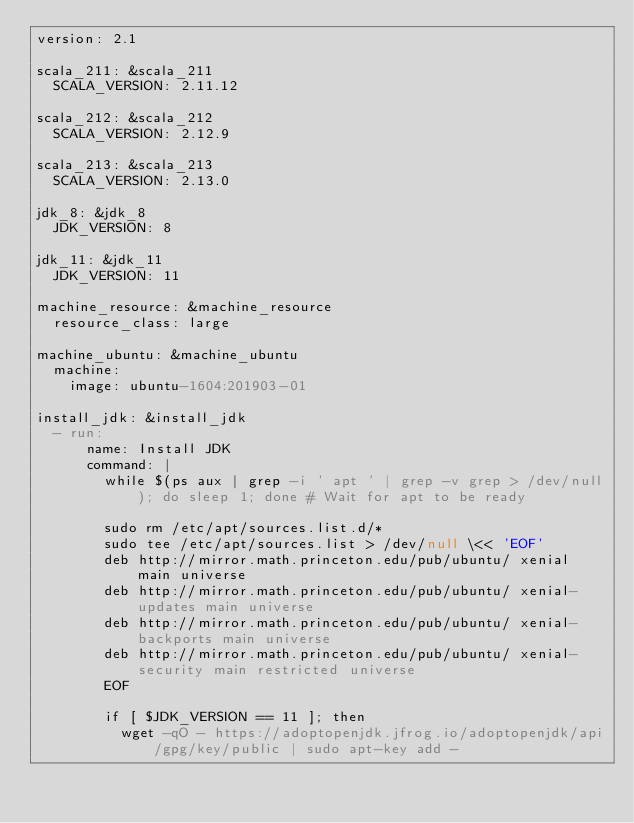Convert code to text. <code><loc_0><loc_0><loc_500><loc_500><_YAML_>version: 2.1

scala_211: &scala_211
  SCALA_VERSION: 2.11.12

scala_212: &scala_212
  SCALA_VERSION: 2.12.9

scala_213: &scala_213
  SCALA_VERSION: 2.13.0

jdk_8: &jdk_8
  JDK_VERSION: 8

jdk_11: &jdk_11
  JDK_VERSION: 11

machine_resource: &machine_resource
  resource_class: large

machine_ubuntu: &machine_ubuntu
  machine:
    image: ubuntu-1604:201903-01

install_jdk: &install_jdk
  - run:
      name: Install JDK
      command: |
        while $(ps aux | grep -i ' apt ' | grep -v grep > /dev/null); do sleep 1; done # Wait for apt to be ready

        sudo rm /etc/apt/sources.list.d/*
        sudo tee /etc/apt/sources.list > /dev/null \<< 'EOF'
        deb http://mirror.math.princeton.edu/pub/ubuntu/ xenial main universe
        deb http://mirror.math.princeton.edu/pub/ubuntu/ xenial-updates main universe
        deb http://mirror.math.princeton.edu/pub/ubuntu/ xenial-backports main universe
        deb http://mirror.math.princeton.edu/pub/ubuntu/ xenial-security main restricted universe
        EOF

        if [ $JDK_VERSION == 11 ]; then
          wget -qO - https://adoptopenjdk.jfrog.io/adoptopenjdk/api/gpg/key/public | sudo apt-key add -</code> 